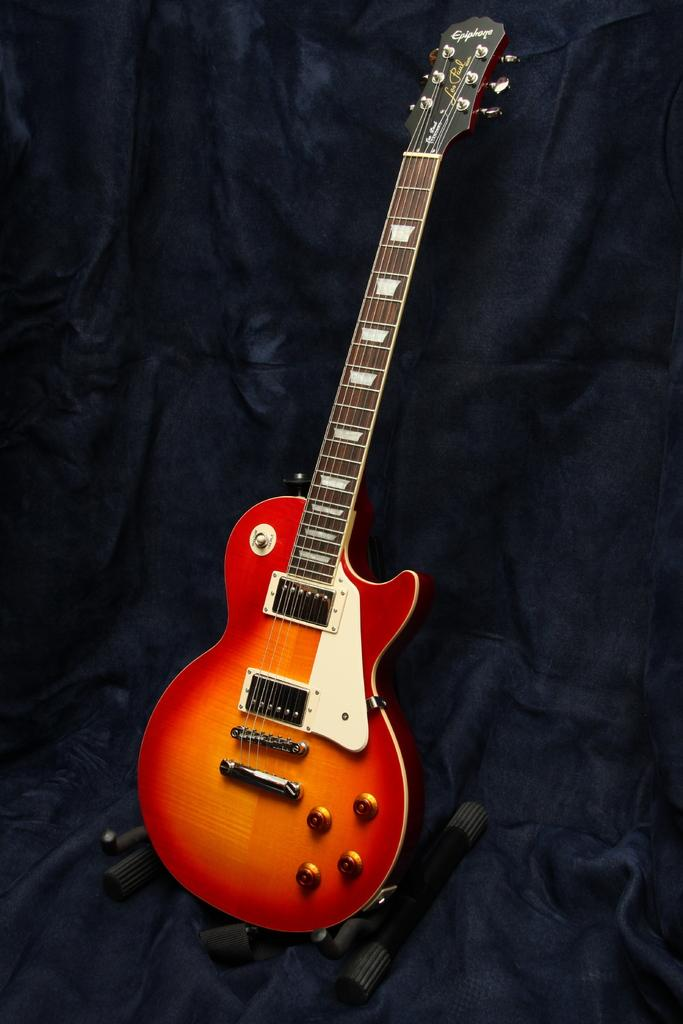What type of musical instrument is in the image? There is a red color guitar in the image. What color is the curtain in the background of the image? There is a blue color curtain in the background of the image. What channel is the guitar tuned to in the image? The guitar is not a television or radio, so it cannot be tuned to a channel. 